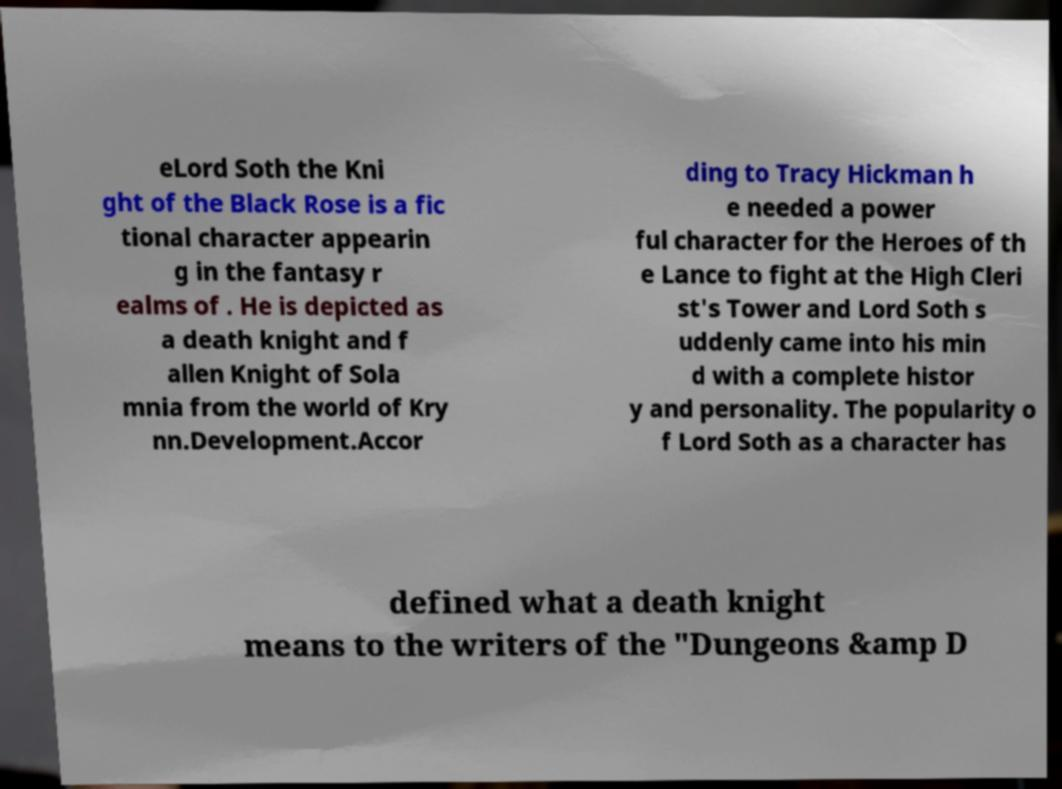Please read and relay the text visible in this image. What does it say? eLord Soth the Kni ght of the Black Rose is a fic tional character appearin g in the fantasy r ealms of . He is depicted as a death knight and f allen Knight of Sola mnia from the world of Kry nn.Development.Accor ding to Tracy Hickman h e needed a power ful character for the Heroes of th e Lance to fight at the High Cleri st's Tower and Lord Soth s uddenly came into his min d with a complete histor y and personality. The popularity o f Lord Soth as a character has defined what a death knight means to the writers of the "Dungeons &amp D 